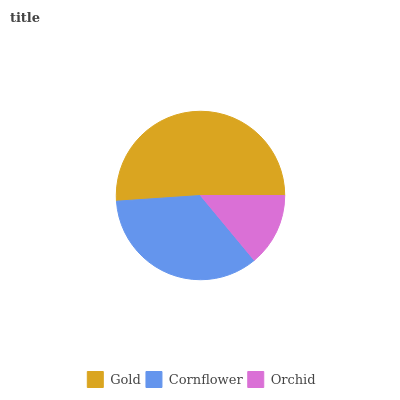Is Orchid the minimum?
Answer yes or no. Yes. Is Gold the maximum?
Answer yes or no. Yes. Is Cornflower the minimum?
Answer yes or no. No. Is Cornflower the maximum?
Answer yes or no. No. Is Gold greater than Cornflower?
Answer yes or no. Yes. Is Cornflower less than Gold?
Answer yes or no. Yes. Is Cornflower greater than Gold?
Answer yes or no. No. Is Gold less than Cornflower?
Answer yes or no. No. Is Cornflower the high median?
Answer yes or no. Yes. Is Cornflower the low median?
Answer yes or no. Yes. Is Gold the high median?
Answer yes or no. No. Is Orchid the low median?
Answer yes or no. No. 